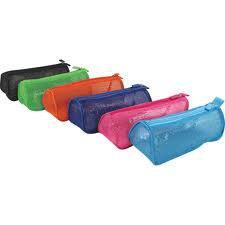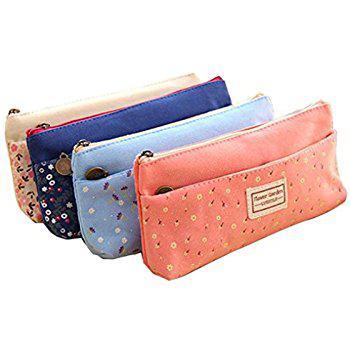The first image is the image on the left, the second image is the image on the right. Analyze the images presented: Is the assertion "There are at least 8 zippered pouches." valid? Answer yes or no. Yes. The first image is the image on the left, the second image is the image on the right. Evaluate the accuracy of this statement regarding the images: "There are four bags/pencil-cases in the left image.". Is it true? Answer yes or no. No. 